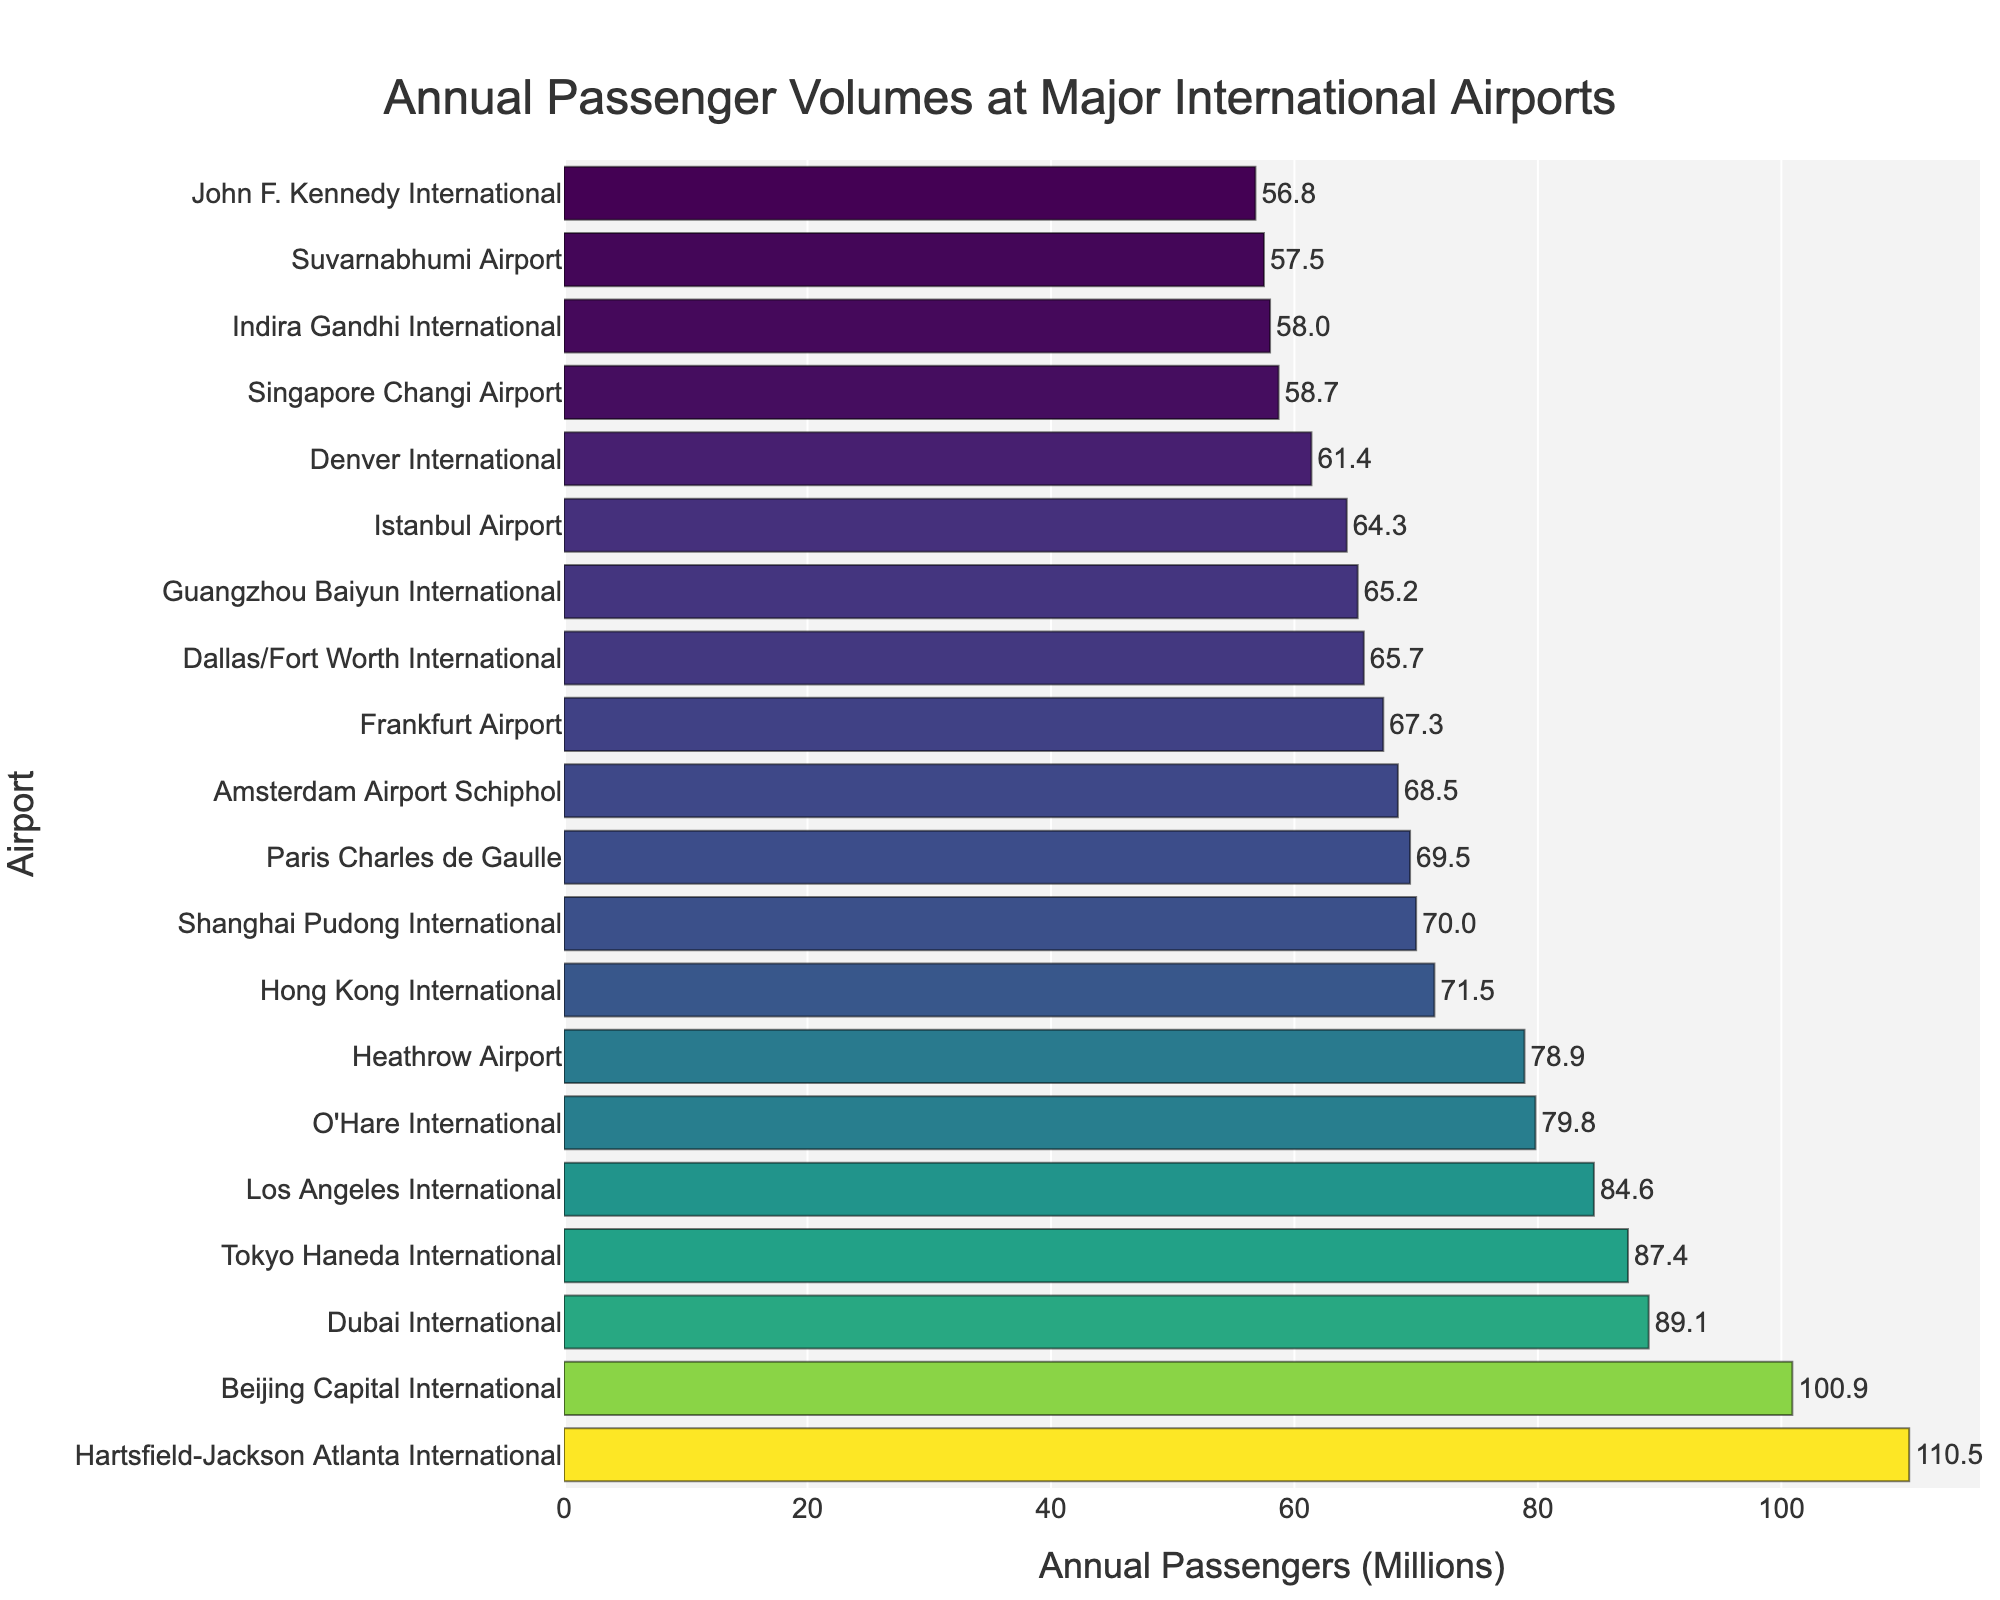Which airport has the highest annual passenger volume? Look at the bar chart and identify the airport with the longest bar. The longest bar represents Hartsfield-Jackson Atlanta International Airport.
Answer: Hartsfield-Jackson Atlanta International What is the total annual passenger volume of the top three airports combined? The top three airports are Hartsfield-Jackson Atlanta International (110.5), Beijing Capital International (100.9), and Dubai International (89.1). Add these values together: 110.5 + 100.9 + 89.1 = 300.5.
Answer: 300.5 million Which airport has more annual passengers, Los Angeles International or Tokyo Haneda International? Compare the lengths of the bars for Los Angeles International (84.6) and Tokyo Haneda International (87.4). Tokyo Haneda International has a longer bar, indicating it has more annual passengers.
Answer: Tokyo Haneda International What is the difference in annual passenger volume between Frankfurt Airport and Amsterdam Airport Schiphol? Find the values for both airports (Frankfurt Airport: 67.3, Amsterdam Airport Schiphol: 68.5). Subtract the smaller value from the larger one: 68.5 - 67.3 = 1.2.
Answer: 1.2 million How many airports have an annual passenger volume greater than 70 million? Count the bars with values greater than 70 million. The airports above 70 million are Hartsfield-Jackson Atlanta, Beijing Capital, Dubai, Tokyo Haneda, Los Angeles International, O'Hare, and Heathrow (7 airports).
Answer: 7 What is the average annual passenger volume of the bottom five airports? Identify the bottom five airports (Indira Gandhi International: 58.0, Suvarnabhumi: 57.5, John F. Kennedy International: 56.8, Denver International: 61.4, Singapore Changi: 58.7). Sum these values: 58.0 + 57.5 + 56.8 + 61.4 + 58.7 = 292.4. Divide by 5 to get the average: 292.4 / 5 = 58.48.
Answer: 58.48 million Which airport has the closest annual passenger volume to 60 million? Compare all values to 60 million and find the one closest to it. Denver International has 61.4, which is the closest to 60 million.
Answer: Denver International What is the median annual passenger volume of all airports listed? List all passenger volumes in ascending order and find the middle value. The sorted values are: [56.8, 57.5, 58.0, 58.7, 61.4, 64.3, 65.2, 65.7, 67.3, 68.5, 69.5, 70.0, 71.5, 78.9, 79.8, 84.6, 87.4, 89.1, 100.9, 110.5]. The median is the average of the 10th and 11th values: (68.5 + 69.5) / 2 = 69.
Answer: 69 million 